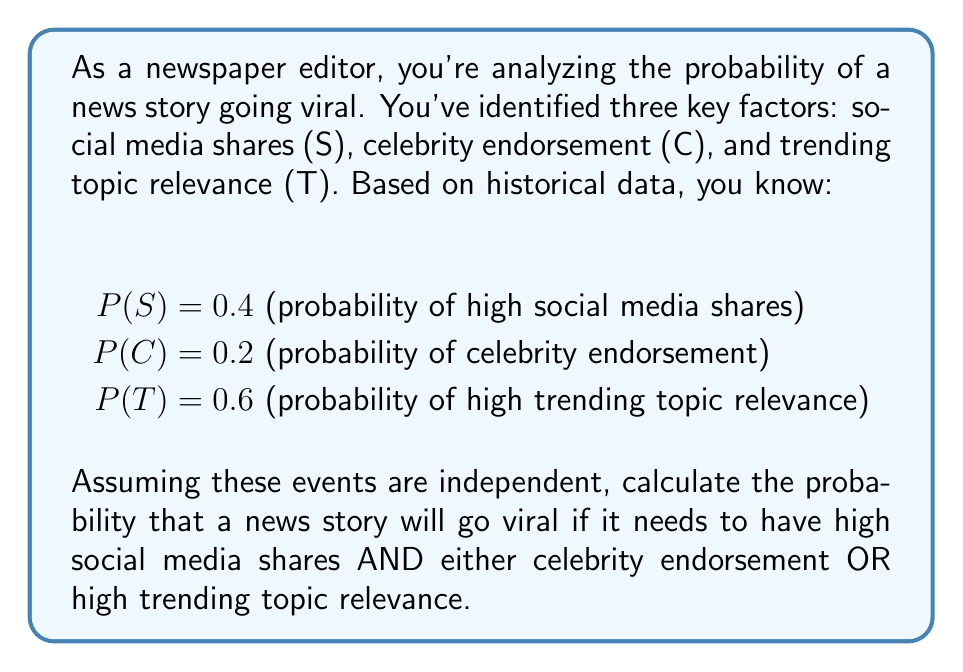Help me with this question. Let's approach this step-by-step:

1) We need to find P(S ∩ (C ∪ T)), which means the probability of S AND (C OR T).

2) Using the given probabilities:
   P(S) = 0.4
   P(C) = 0.2
   P(T) = 0.6

3) First, let's calculate P(C ∪ T):
   P(C ∪ T) = P(C) + P(T) - P(C ∩ T)
   Since C and T are independent:
   P(C ∩ T) = P(C) × P(T) = 0.2 × 0.6 = 0.12
   Therefore:
   P(C ∪ T) = 0.2 + 0.6 - 0.12 = 0.68

4) Now, we can calculate P(S ∩ (C ∪ T)):
   Since S is independent of (C ∪ T):
   P(S ∩ (C ∪ T)) = P(S) × P(C ∪ T)
   
5) Substituting the values:
   P(S ∩ (C ∪ T)) = 0.4 × 0.68 = 0.272

Therefore, the probability of a news story going viral under these conditions is 0.272 or 27.2%.
Answer: 0.272 